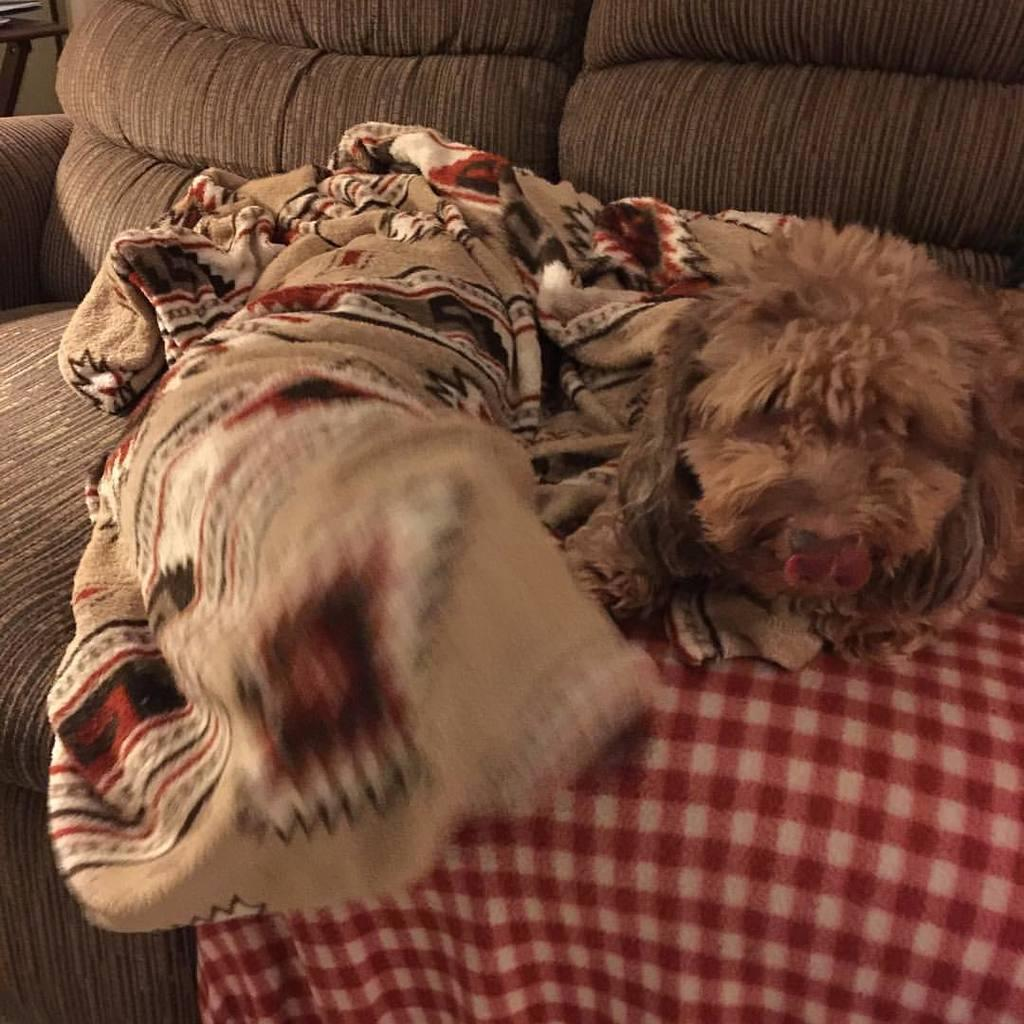What type of furniture is in the image? There is a sofa in the image. What type of fabric is visible in the image? There is a bed sheet and a cloth in the image. What animal is present on the sofa? There is a dog present on the sofa. What type of necklace is the dog wearing in the image? There is no necklace present on the dog in the image. How many chickens are visible in the image? There are no chickens present in the image. 